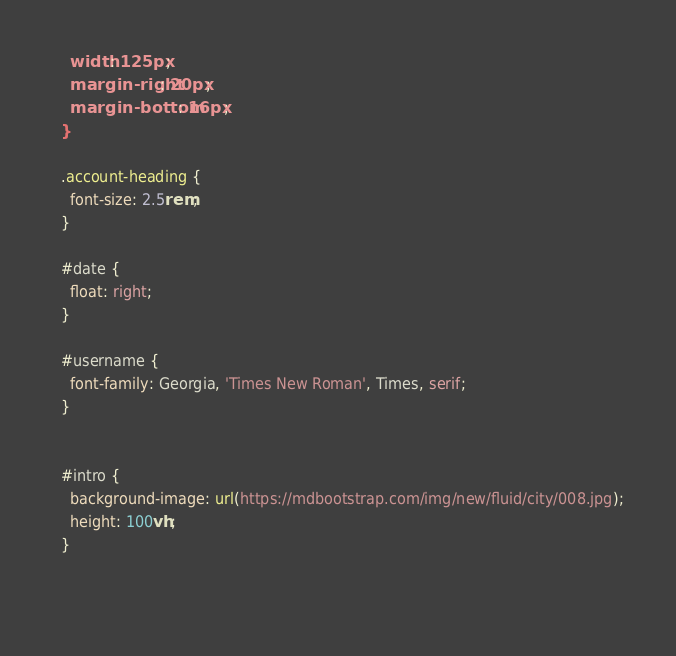<code> <loc_0><loc_0><loc_500><loc_500><_CSS_>    width: 125px;
    margin-right: 20px;
    margin-bottom: 16px;
  }
  
  .account-heading {
    font-size: 2.5rem;
  }
  
  #date {
    float: right;
  }
    
  #username {
    font-family: Georgia, 'Times New Roman', Times, serif;
  }


  #intro {
    background-image: url(https://mdbootstrap.com/img/new/fluid/city/008.jpg);
    height: 100vh;
  }
    
    </code> 